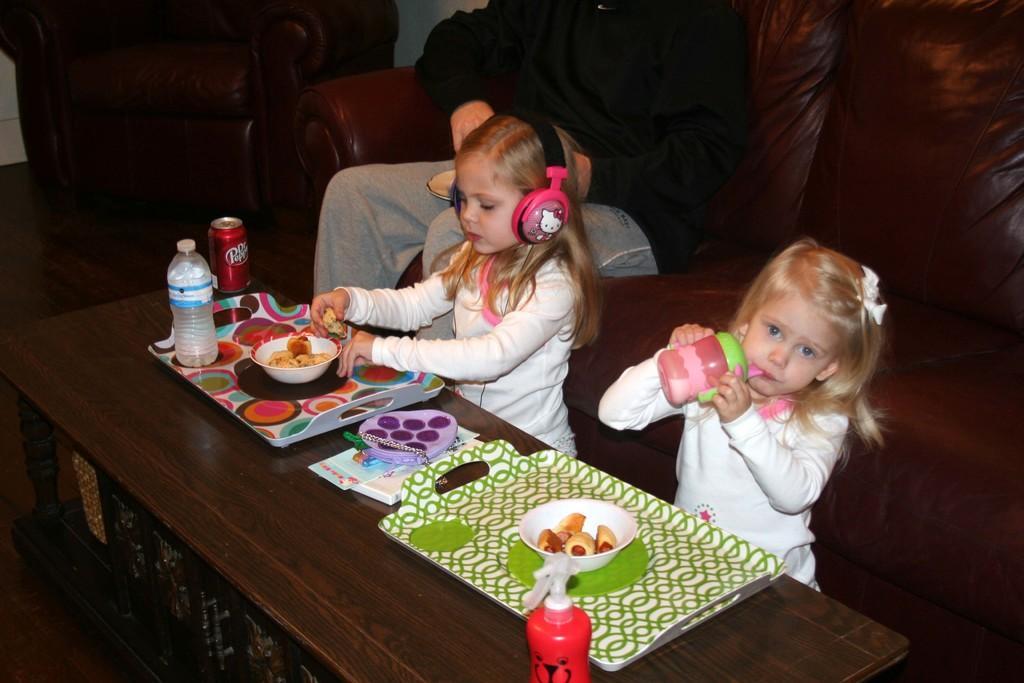Could you give a brief overview of what you see in this image? In this image I can see two girls wearing white t-shirts and sitting in front of the table. one girl is wearing headset. on the table I can see two trays, one bottle, one cock-tin and two bowls and some food items in it. In the background I can see a person wearing black shirt and sitting on the sofa and holding one plate. 